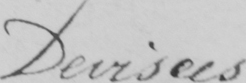What is written in this line of handwriting? Devisees 